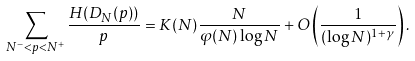<formula> <loc_0><loc_0><loc_500><loc_500>\sum _ { N ^ { - } < p < N ^ { + } } \frac { H ( D _ { N } ( p ) ) } { p } = K ( N ) \frac { N } { \varphi ( N ) \log N } + O \left ( \frac { 1 } { ( \log N ) ^ { 1 + \gamma } } \right ) .</formula> 